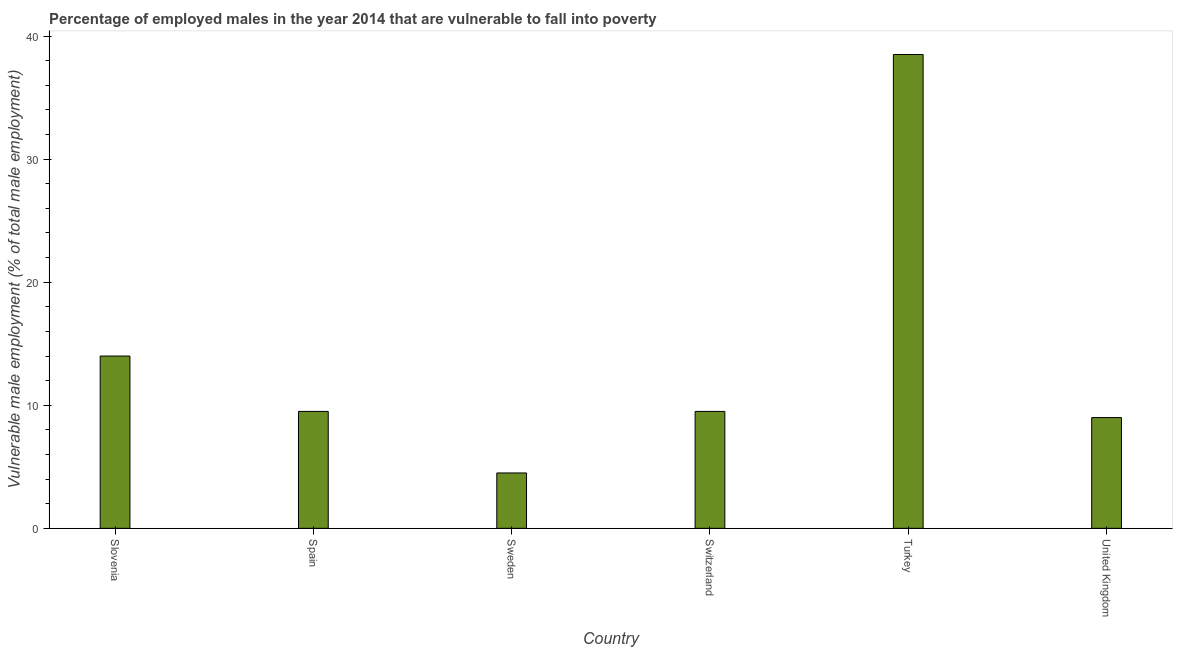Does the graph contain any zero values?
Keep it short and to the point. No. Does the graph contain grids?
Offer a terse response. No. What is the title of the graph?
Give a very brief answer. Percentage of employed males in the year 2014 that are vulnerable to fall into poverty. What is the label or title of the Y-axis?
Provide a short and direct response. Vulnerable male employment (% of total male employment). What is the percentage of employed males who are vulnerable to fall into poverty in United Kingdom?
Your answer should be compact. 9. Across all countries, what is the maximum percentage of employed males who are vulnerable to fall into poverty?
Your response must be concise. 38.5. Across all countries, what is the minimum percentage of employed males who are vulnerable to fall into poverty?
Keep it short and to the point. 4.5. In which country was the percentage of employed males who are vulnerable to fall into poverty maximum?
Your response must be concise. Turkey. What is the sum of the percentage of employed males who are vulnerable to fall into poverty?
Offer a terse response. 85. What is the average percentage of employed males who are vulnerable to fall into poverty per country?
Your answer should be very brief. 14.17. What is the median percentage of employed males who are vulnerable to fall into poverty?
Ensure brevity in your answer.  9.5. What is the ratio of the percentage of employed males who are vulnerable to fall into poverty in Switzerland to that in Turkey?
Give a very brief answer. 0.25. Is the percentage of employed males who are vulnerable to fall into poverty in Slovenia less than that in Switzerland?
Offer a terse response. No. Is the difference between the percentage of employed males who are vulnerable to fall into poverty in Sweden and Switzerland greater than the difference between any two countries?
Make the answer very short. No. What is the difference between the highest and the second highest percentage of employed males who are vulnerable to fall into poverty?
Ensure brevity in your answer.  24.5. How many bars are there?
Give a very brief answer. 6. Are all the bars in the graph horizontal?
Make the answer very short. No. How many countries are there in the graph?
Offer a very short reply. 6. What is the Vulnerable male employment (% of total male employment) in Slovenia?
Provide a short and direct response. 14. What is the Vulnerable male employment (% of total male employment) of Sweden?
Offer a very short reply. 4.5. What is the Vulnerable male employment (% of total male employment) of Turkey?
Your response must be concise. 38.5. What is the difference between the Vulnerable male employment (% of total male employment) in Slovenia and Spain?
Ensure brevity in your answer.  4.5. What is the difference between the Vulnerable male employment (% of total male employment) in Slovenia and Sweden?
Ensure brevity in your answer.  9.5. What is the difference between the Vulnerable male employment (% of total male employment) in Slovenia and Switzerland?
Keep it short and to the point. 4.5. What is the difference between the Vulnerable male employment (% of total male employment) in Slovenia and Turkey?
Provide a short and direct response. -24.5. What is the difference between the Vulnerable male employment (% of total male employment) in Slovenia and United Kingdom?
Keep it short and to the point. 5. What is the difference between the Vulnerable male employment (% of total male employment) in Spain and Sweden?
Your answer should be compact. 5. What is the difference between the Vulnerable male employment (% of total male employment) in Spain and Switzerland?
Make the answer very short. 0. What is the difference between the Vulnerable male employment (% of total male employment) in Sweden and Turkey?
Your response must be concise. -34. What is the difference between the Vulnerable male employment (% of total male employment) in Turkey and United Kingdom?
Your response must be concise. 29.5. What is the ratio of the Vulnerable male employment (% of total male employment) in Slovenia to that in Spain?
Your answer should be compact. 1.47. What is the ratio of the Vulnerable male employment (% of total male employment) in Slovenia to that in Sweden?
Your response must be concise. 3.11. What is the ratio of the Vulnerable male employment (% of total male employment) in Slovenia to that in Switzerland?
Provide a short and direct response. 1.47. What is the ratio of the Vulnerable male employment (% of total male employment) in Slovenia to that in Turkey?
Your answer should be very brief. 0.36. What is the ratio of the Vulnerable male employment (% of total male employment) in Slovenia to that in United Kingdom?
Your response must be concise. 1.56. What is the ratio of the Vulnerable male employment (% of total male employment) in Spain to that in Sweden?
Offer a very short reply. 2.11. What is the ratio of the Vulnerable male employment (% of total male employment) in Spain to that in Turkey?
Provide a succinct answer. 0.25. What is the ratio of the Vulnerable male employment (% of total male employment) in Spain to that in United Kingdom?
Your response must be concise. 1.06. What is the ratio of the Vulnerable male employment (% of total male employment) in Sweden to that in Switzerland?
Your answer should be compact. 0.47. What is the ratio of the Vulnerable male employment (% of total male employment) in Sweden to that in Turkey?
Provide a short and direct response. 0.12. What is the ratio of the Vulnerable male employment (% of total male employment) in Sweden to that in United Kingdom?
Your response must be concise. 0.5. What is the ratio of the Vulnerable male employment (% of total male employment) in Switzerland to that in Turkey?
Make the answer very short. 0.25. What is the ratio of the Vulnerable male employment (% of total male employment) in Switzerland to that in United Kingdom?
Your response must be concise. 1.06. What is the ratio of the Vulnerable male employment (% of total male employment) in Turkey to that in United Kingdom?
Provide a succinct answer. 4.28. 